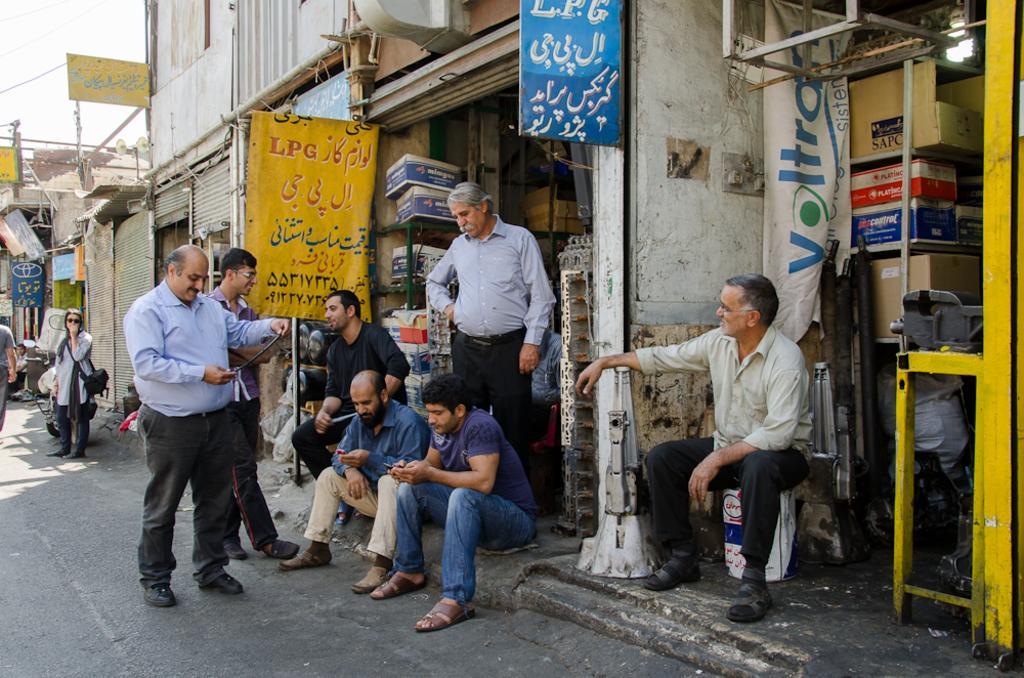How would you summarize this image in a sentence or two? This image is taken outdoors. At the bottom of the image there is a road. On the left side of the image a man is walking on the road and a woman is standing on the road. A bike is parked on the road. In the middle of the image are a few buildings with shutters and walls. There are many boards with text on them. On the right side of the image there are a few cardboard boxes on the shelves and there is a banner with a text on them. A man is sitting on the bucket. Three men are standing on the road and three men are sitting. 